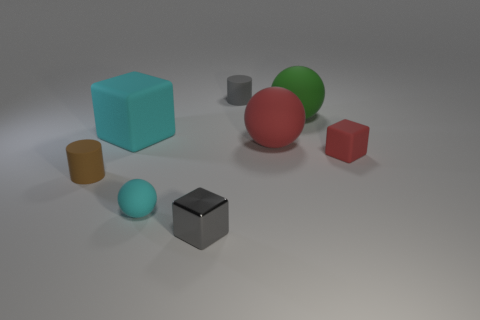Add 2 tiny brown rubber objects. How many objects exist? 10 Subtract all spheres. How many objects are left? 5 Add 2 red balls. How many red balls are left? 3 Add 8 large green matte things. How many large green matte things exist? 9 Subtract 0 blue cylinders. How many objects are left? 8 Subtract all matte things. Subtract all small gray metallic things. How many objects are left? 0 